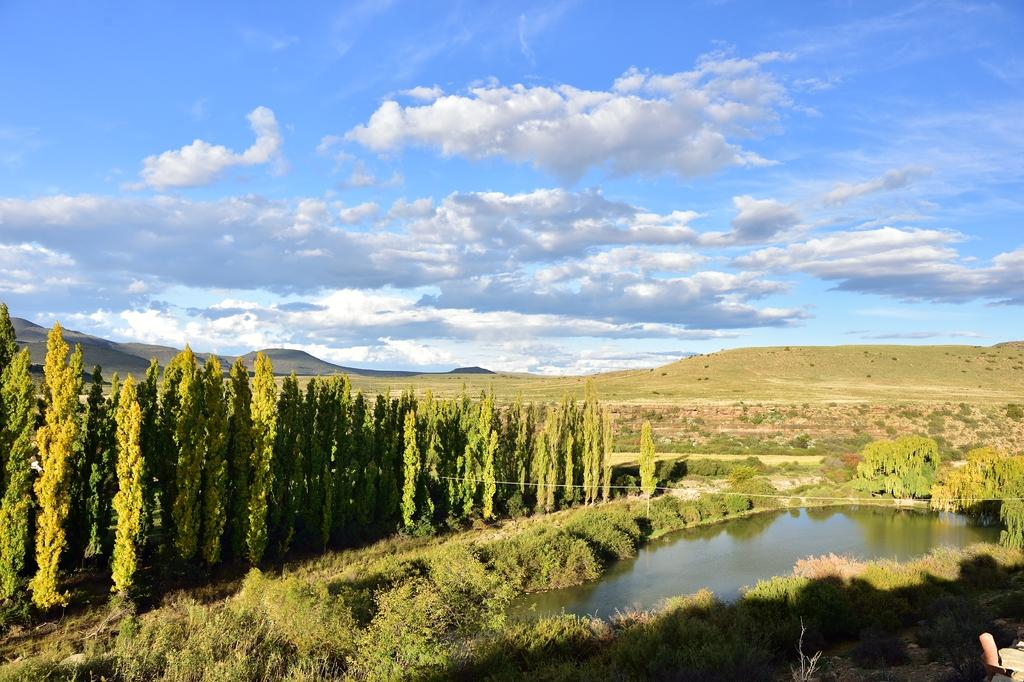What type of vegetation can be seen in the image? There are trees in the image. What else can be seen on the ground in the image? There is grass in the image. What is visible in the image besides the vegetation? Water and the sky are visible in the image. What can be seen in the sky in the image? There are clouds in the image. What type of suit is the team wearing in the lunchroom in the image? There is no lunchroom, suit, or team present in the image. 